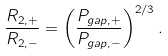Convert formula to latex. <formula><loc_0><loc_0><loc_500><loc_500>\frac { R _ { 2 , + } } { R _ { 2 , - } } = \left ( \frac { P _ { g a p , + } } { P _ { g a p , - } } \right ) ^ { 2 / 3 } .</formula> 